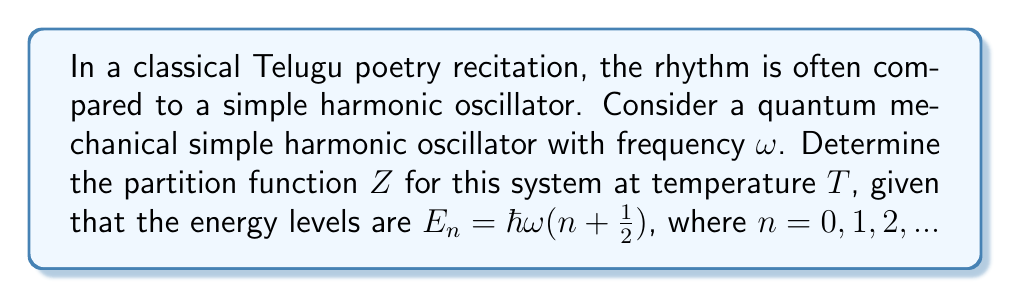Could you help me with this problem? To determine the partition function, we follow these steps:

1) The partition function $Z$ is defined as:
   $$Z = \sum_{n=0}^{\infty} e^{-\beta E_n}$$
   where $\beta = \frac{1}{k_B T}$, $k_B$ is Boltzmann's constant, and $T$ is temperature.

2) Substitute the energy levels:
   $$Z = \sum_{n=0}^{\infty} e^{-\beta \hbar \omega (n + \frac{1}{2})}$$

3) Factor out the constant term:
   $$Z = e^{-\beta \hbar \omega / 2} \sum_{n=0}^{\infty} (e^{-\beta \hbar \omega})^n$$

4) Recognize this as a geometric series with $r = e^{-\beta \hbar \omega}$:
   $$Z = e^{-\beta \hbar \omega / 2} \frac{1}{1 - e^{-\beta \hbar \omega}}$$

5) Simplify:
   $$Z = \frac{e^{-\beta \hbar \omega / 2}}{1 - e^{-\beta \hbar \omega}}$$

6) This can be further simplified by multiplying numerator and denominator by $e^{\beta \hbar \omega / 2}$:
   $$Z = \frac{1}{e^{\beta \hbar \omega / 2} - e^{-\beta \hbar \omega / 2}}$$

7) Recognize the denominator as twice the hyperbolic sine:
   $$Z = \frac{1}{2 \sinh(\beta \hbar \omega / 2)}$$
Answer: $Z = \frac{1}{2 \sinh(\frac{\hbar \omega}{2k_B T})}$ 